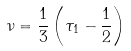<formula> <loc_0><loc_0><loc_500><loc_500>\nu = \frac { 1 } { 3 } \left ( \tau _ { 1 } - \frac { 1 } { 2 } \right )</formula> 